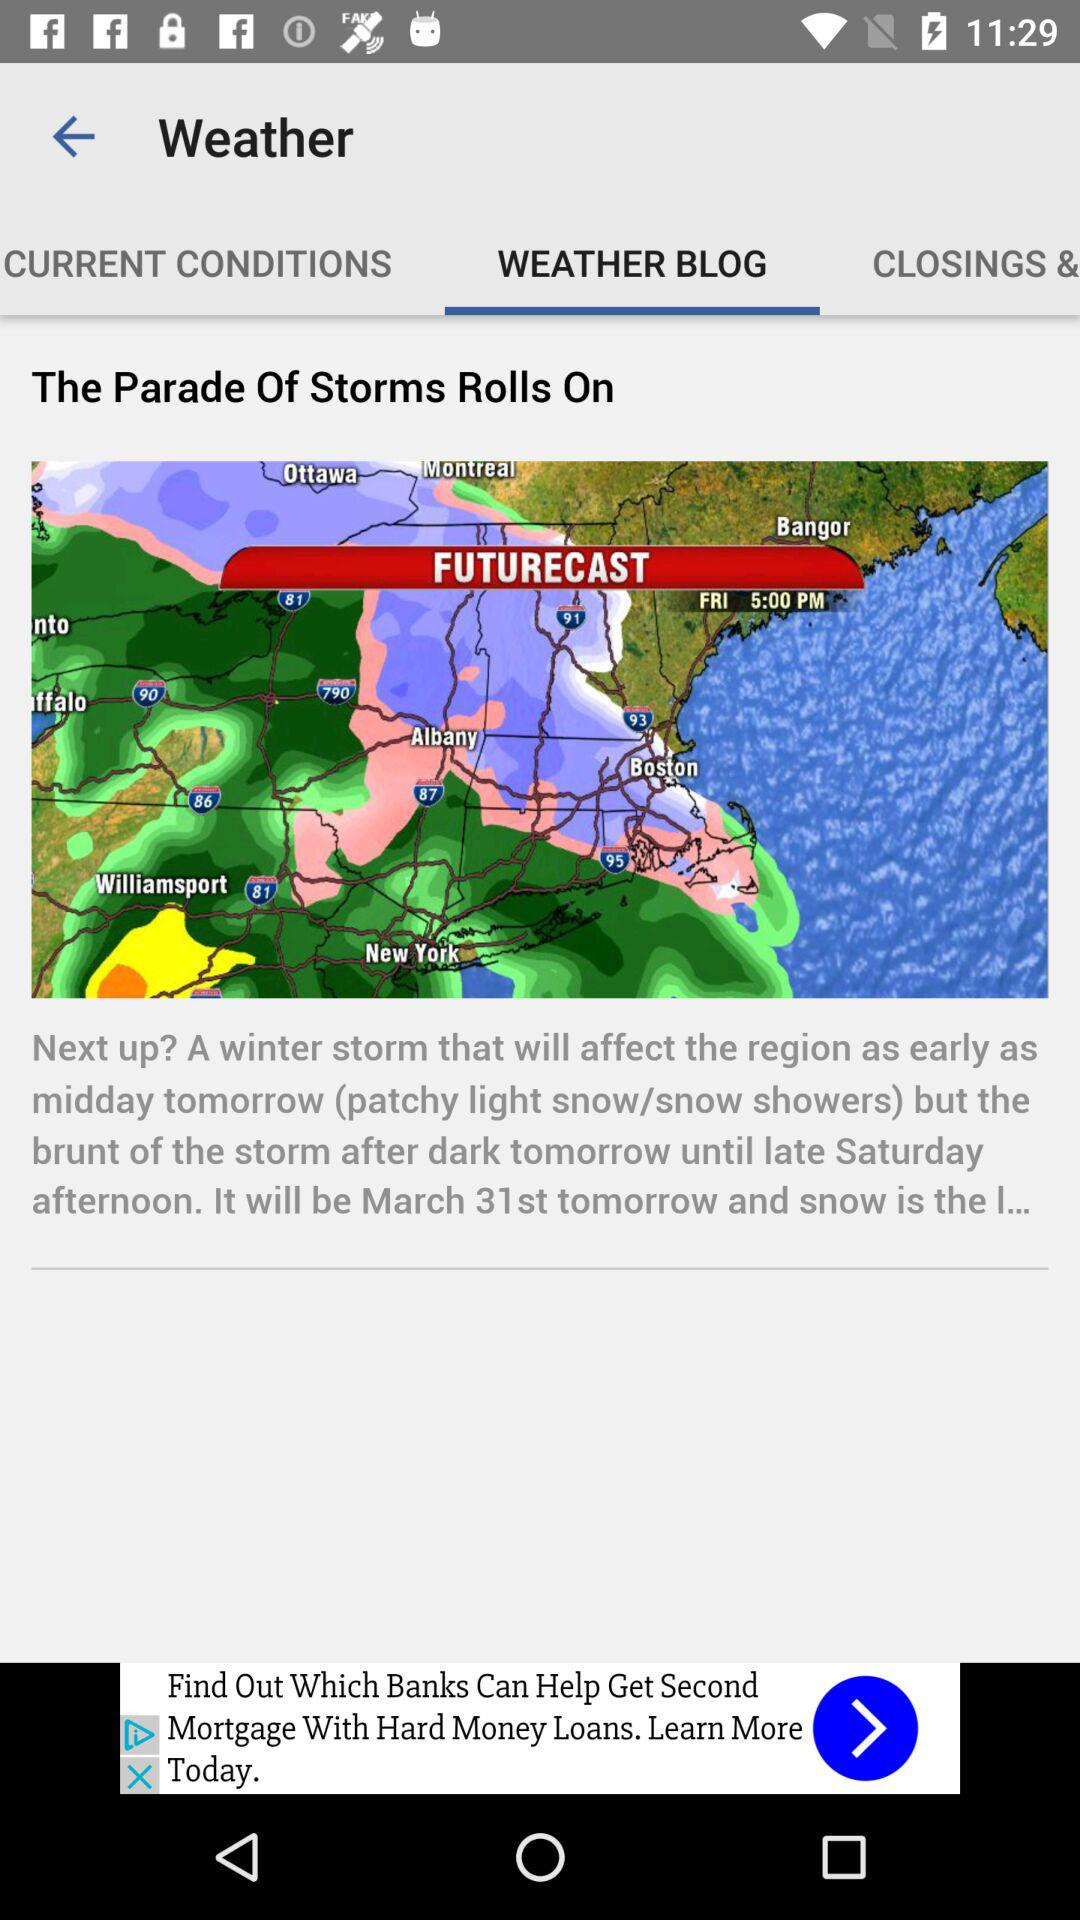What is the date tomorrow? The date tomorrow is March 31st. 